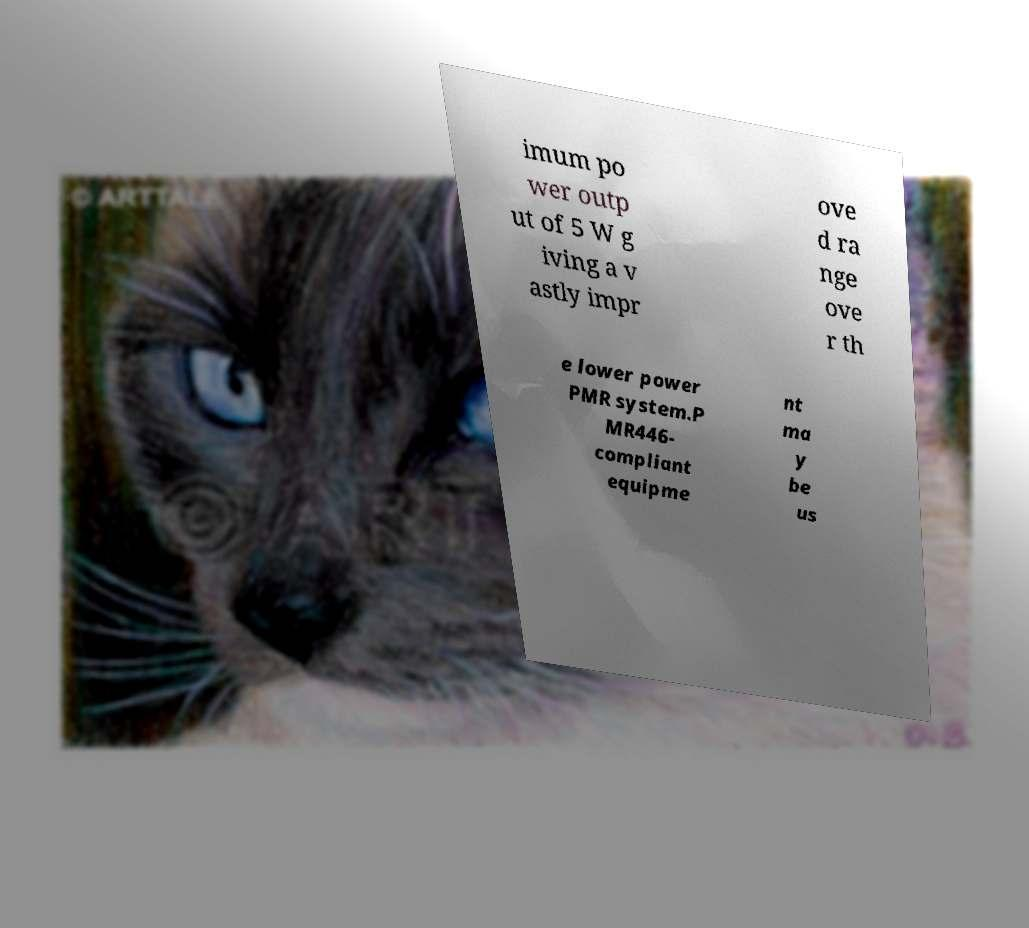Could you extract and type out the text from this image? imum po wer outp ut of 5 W g iving a v astly impr ove d ra nge ove r th e lower power PMR system.P MR446- compliant equipme nt ma y be us 